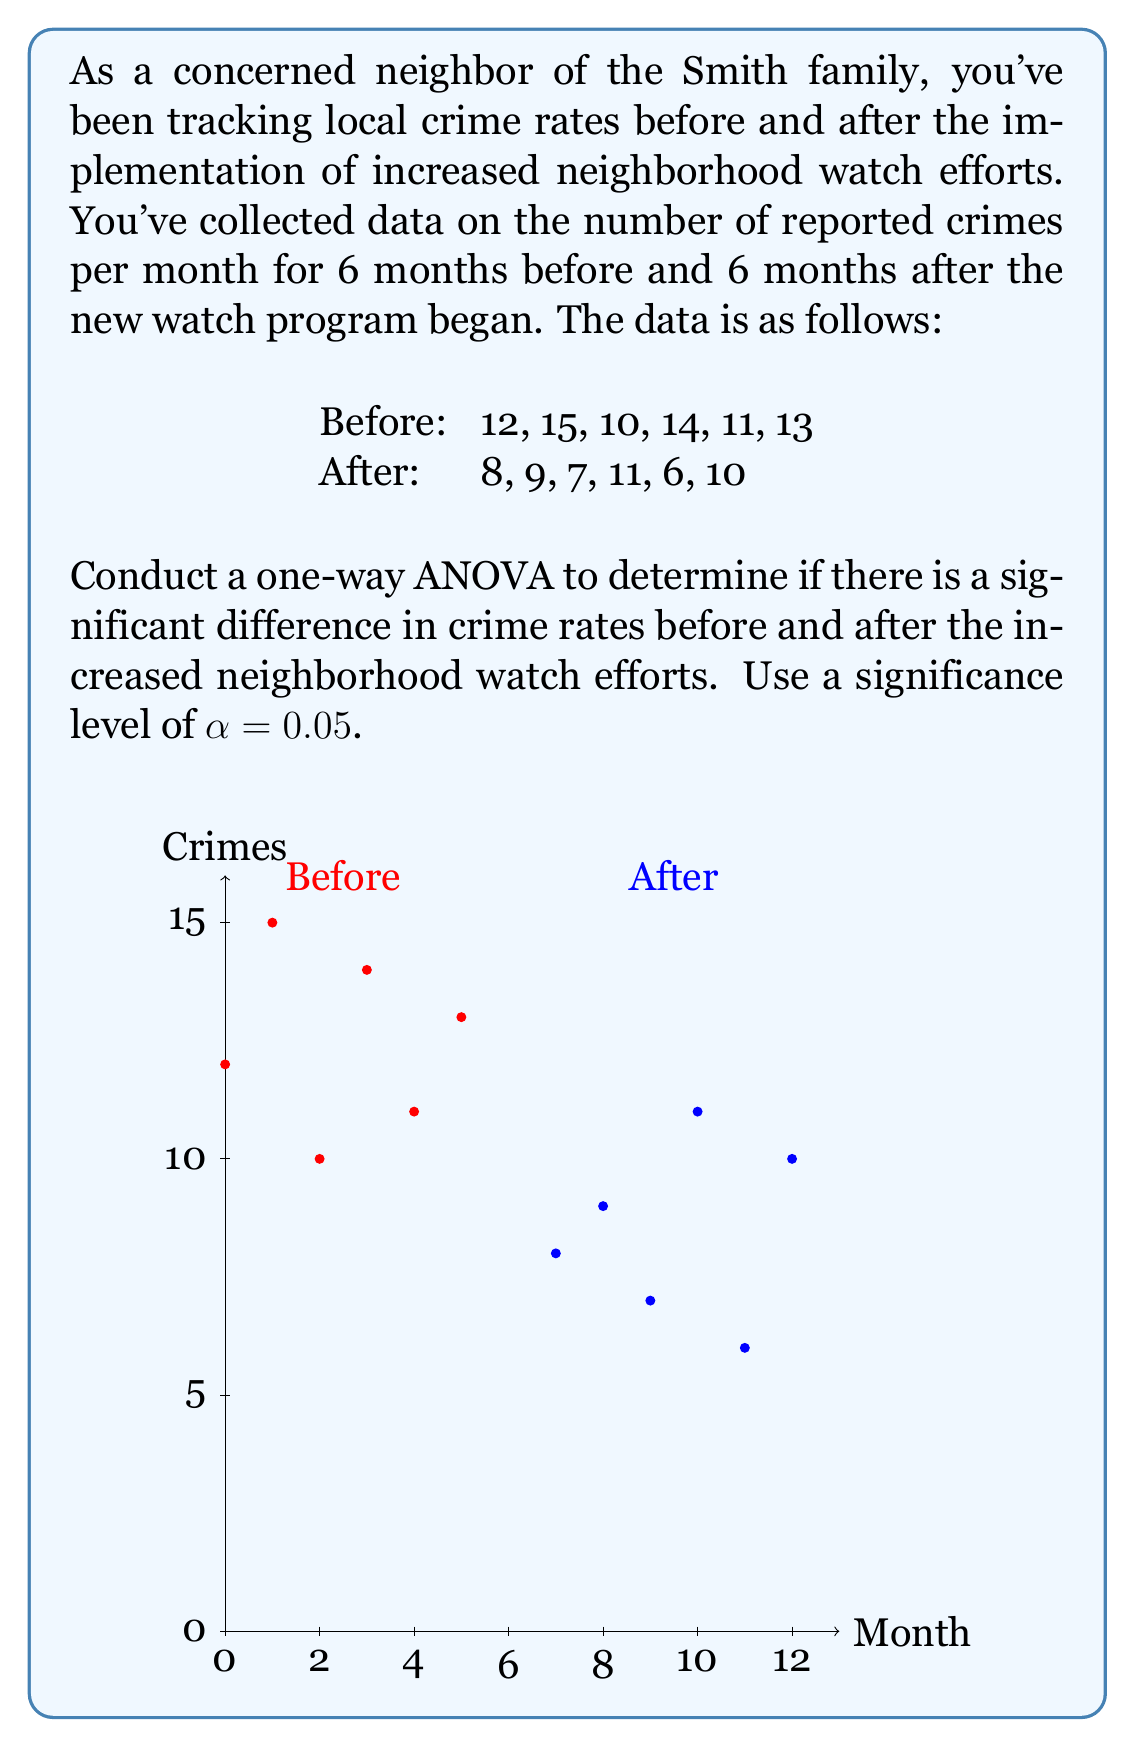What is the answer to this math problem? To conduct a one-way ANOVA, we'll follow these steps:

1. Calculate the means for each group:
   Before: $\bar{X}_1 = \frac{12 + 15 + 10 + 14 + 11 + 13}{6} = 12.5$
   After: $\bar{X}_2 = \frac{8 + 9 + 7 + 11 + 6 + 10}{6} = 8.5$

2. Calculate the grand mean:
   $\bar{X} = \frac{12.5 + 8.5}{2} = 10.5$

3. Calculate the Sum of Squares Between (SSB):
   $SSB = \sum n_i(\bar{X}_i - \bar{X})^2$
   $SSB = 6(12.5 - 10.5)^2 + 6(8.5 - 10.5)^2 = 6(2)^2 + 6(-2)^2 = 48$

4. Calculate the Sum of Squares Within (SSW):
   $SSW = \sum\sum(X_{ij} - \bar{X}_i)^2$
   Before: $(12-12.5)^2 + (15-12.5)^2 + (10-12.5)^2 + (14-12.5)^2 + (11-12.5)^2 + (13-12.5)^2 = 20.5$
   After: $(8-8.5)^2 + (9-8.5)^2 + (7-8.5)^2 + (11-8.5)^2 + (6-8.5)^2 + (10-8.5)^2 = 22.5$
   $SSW = 20.5 + 22.5 = 43$

5. Calculate degrees of freedom:
   $df_{between} = k - 1 = 2 - 1 = 1$
   $df_{within} = N - k = 12 - 2 = 10$

6. Calculate Mean Square Between (MSB) and Mean Square Within (MSW):
   $MSB = \frac{SSB}{df_{between}} = \frac{48}{1} = 48$
   $MSW = \frac{SSW}{df_{within}} = \frac{43}{10} = 4.3$

7. Calculate the F-statistic:
   $F = \frac{MSB}{MSW} = \frac{48}{4.3} = 11.16$

8. Find the critical F-value:
   For $\alpha = 0.05$, $df_{between} = 1$, and $df_{within} = 10$, the critical F-value is approximately 4.96.

9. Compare the F-statistic to the critical F-value:
   Since $11.16 > 4.96$, we reject the null hypothesis.
Answer: $F(1, 10) = 11.16, p < 0.05$. Significant difference in crime rates. 